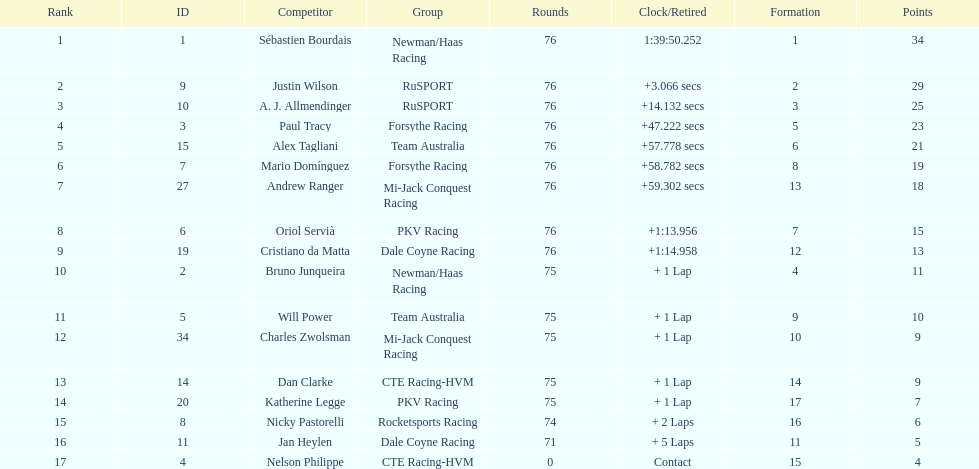Which driver has the least amount of points? Nelson Philippe. Give me the full table as a dictionary. {'header': ['Rank', 'ID', 'Competitor', 'Group', 'Rounds', 'Clock/Retired', 'Formation', 'Points'], 'rows': [['1', '1', 'Sébastien Bourdais', 'Newman/Haas Racing', '76', '1:39:50.252', '1', '34'], ['2', '9', 'Justin Wilson', 'RuSPORT', '76', '+3.066 secs', '2', '29'], ['3', '10', 'A. J. Allmendinger', 'RuSPORT', '76', '+14.132 secs', '3', '25'], ['4', '3', 'Paul Tracy', 'Forsythe Racing', '76', '+47.222 secs', '5', '23'], ['5', '15', 'Alex Tagliani', 'Team Australia', '76', '+57.778 secs', '6', '21'], ['6', '7', 'Mario Domínguez', 'Forsythe Racing', '76', '+58.782 secs', '8', '19'], ['7', '27', 'Andrew Ranger', 'Mi-Jack Conquest Racing', '76', '+59.302 secs', '13', '18'], ['8', '6', 'Oriol Servià', 'PKV Racing', '76', '+1:13.956', '7', '15'], ['9', '19', 'Cristiano da Matta', 'Dale Coyne Racing', '76', '+1:14.958', '12', '13'], ['10', '2', 'Bruno Junqueira', 'Newman/Haas Racing', '75', '+ 1 Lap', '4', '11'], ['11', '5', 'Will Power', 'Team Australia', '75', '+ 1 Lap', '9', '10'], ['12', '34', 'Charles Zwolsman', 'Mi-Jack Conquest Racing', '75', '+ 1 Lap', '10', '9'], ['13', '14', 'Dan Clarke', 'CTE Racing-HVM', '75', '+ 1 Lap', '14', '9'], ['14', '20', 'Katherine Legge', 'PKV Racing', '75', '+ 1 Lap', '17', '7'], ['15', '8', 'Nicky Pastorelli', 'Rocketsports Racing', '74', '+ 2 Laps', '16', '6'], ['16', '11', 'Jan Heylen', 'Dale Coyne Racing', '71', '+ 5 Laps', '11', '5'], ['17', '4', 'Nelson Philippe', 'CTE Racing-HVM', '0', 'Contact', '15', '4']]} 